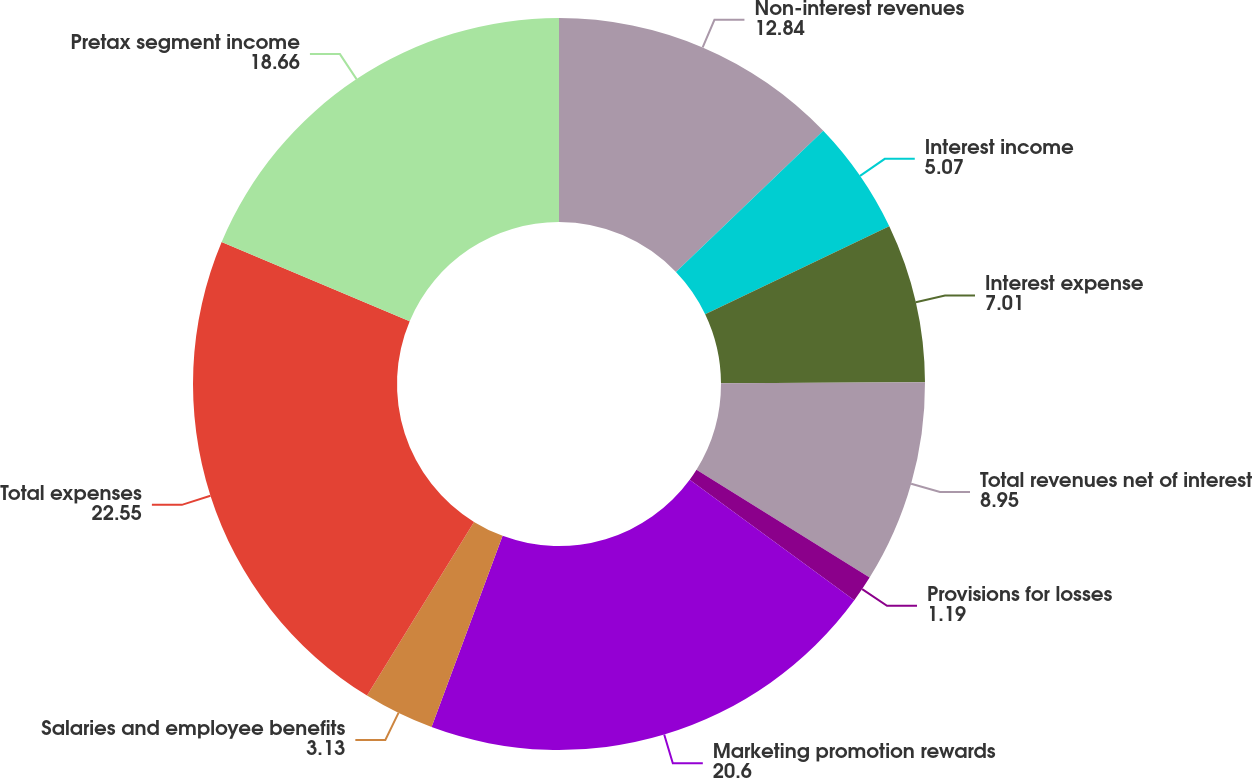Convert chart to OTSL. <chart><loc_0><loc_0><loc_500><loc_500><pie_chart><fcel>Non-interest revenues<fcel>Interest income<fcel>Interest expense<fcel>Total revenues net of interest<fcel>Provisions for losses<fcel>Marketing promotion rewards<fcel>Salaries and employee benefits<fcel>Total expenses<fcel>Pretax segment income<nl><fcel>12.84%<fcel>5.07%<fcel>7.01%<fcel>8.95%<fcel>1.19%<fcel>20.6%<fcel>3.13%<fcel>22.55%<fcel>18.66%<nl></chart> 